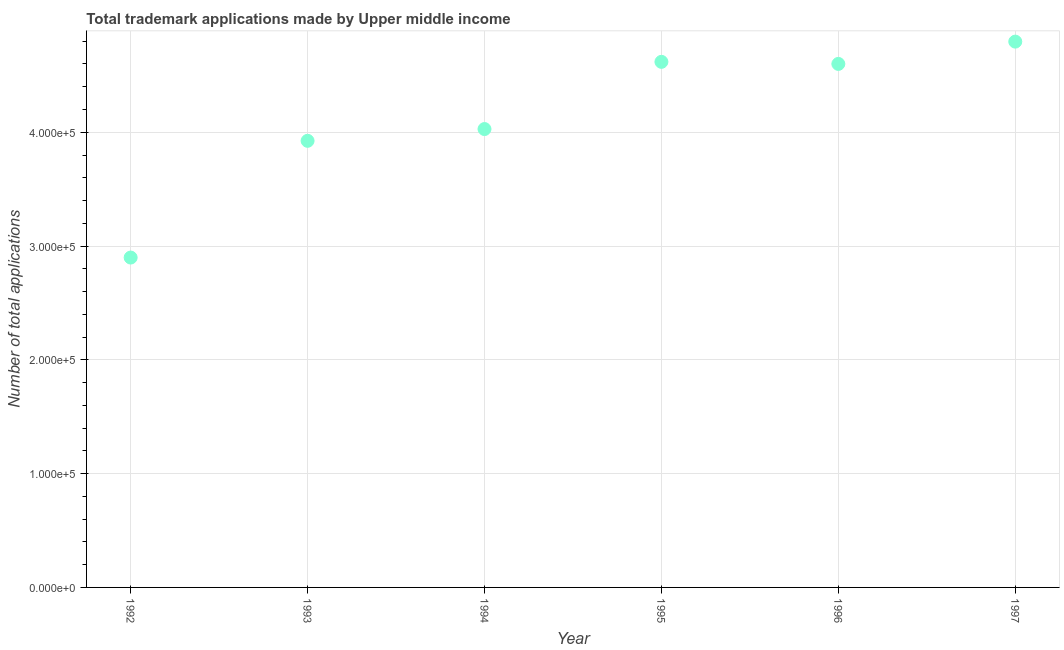What is the number of trademark applications in 1994?
Provide a short and direct response. 4.03e+05. Across all years, what is the maximum number of trademark applications?
Provide a short and direct response. 4.80e+05. Across all years, what is the minimum number of trademark applications?
Keep it short and to the point. 2.90e+05. In which year was the number of trademark applications maximum?
Your response must be concise. 1997. In which year was the number of trademark applications minimum?
Your answer should be very brief. 1992. What is the sum of the number of trademark applications?
Offer a very short reply. 2.49e+06. What is the difference between the number of trademark applications in 1992 and 1996?
Offer a terse response. -1.70e+05. What is the average number of trademark applications per year?
Provide a succinct answer. 4.14e+05. What is the median number of trademark applications?
Offer a very short reply. 4.31e+05. Do a majority of the years between 1992 and 1996 (inclusive) have number of trademark applications greater than 40000 ?
Provide a short and direct response. Yes. What is the ratio of the number of trademark applications in 1994 to that in 1995?
Your answer should be very brief. 0.87. Is the number of trademark applications in 1996 less than that in 1997?
Keep it short and to the point. Yes. What is the difference between the highest and the second highest number of trademark applications?
Make the answer very short. 1.78e+04. Is the sum of the number of trademark applications in 1993 and 1997 greater than the maximum number of trademark applications across all years?
Ensure brevity in your answer.  Yes. What is the difference between the highest and the lowest number of trademark applications?
Give a very brief answer. 1.90e+05. In how many years, is the number of trademark applications greater than the average number of trademark applications taken over all years?
Make the answer very short. 3. How many years are there in the graph?
Give a very brief answer. 6. Are the values on the major ticks of Y-axis written in scientific E-notation?
Keep it short and to the point. Yes. What is the title of the graph?
Offer a terse response. Total trademark applications made by Upper middle income. What is the label or title of the Y-axis?
Provide a short and direct response. Number of total applications. What is the Number of total applications in 1992?
Your answer should be compact. 2.90e+05. What is the Number of total applications in 1993?
Make the answer very short. 3.92e+05. What is the Number of total applications in 1994?
Give a very brief answer. 4.03e+05. What is the Number of total applications in 1995?
Provide a succinct answer. 4.62e+05. What is the Number of total applications in 1996?
Provide a succinct answer. 4.60e+05. What is the Number of total applications in 1997?
Your answer should be very brief. 4.80e+05. What is the difference between the Number of total applications in 1992 and 1993?
Ensure brevity in your answer.  -1.03e+05. What is the difference between the Number of total applications in 1992 and 1994?
Make the answer very short. -1.13e+05. What is the difference between the Number of total applications in 1992 and 1995?
Give a very brief answer. -1.72e+05. What is the difference between the Number of total applications in 1992 and 1996?
Your response must be concise. -1.70e+05. What is the difference between the Number of total applications in 1992 and 1997?
Offer a terse response. -1.90e+05. What is the difference between the Number of total applications in 1993 and 1994?
Ensure brevity in your answer.  -1.03e+04. What is the difference between the Number of total applications in 1993 and 1995?
Your response must be concise. -6.94e+04. What is the difference between the Number of total applications in 1993 and 1996?
Your answer should be compact. -6.76e+04. What is the difference between the Number of total applications in 1993 and 1997?
Your answer should be very brief. -8.72e+04. What is the difference between the Number of total applications in 1994 and 1995?
Make the answer very short. -5.90e+04. What is the difference between the Number of total applications in 1994 and 1996?
Offer a very short reply. -5.72e+04. What is the difference between the Number of total applications in 1994 and 1997?
Offer a very short reply. -7.68e+04. What is the difference between the Number of total applications in 1995 and 1996?
Your response must be concise. 1810. What is the difference between the Number of total applications in 1995 and 1997?
Ensure brevity in your answer.  -1.78e+04. What is the difference between the Number of total applications in 1996 and 1997?
Ensure brevity in your answer.  -1.96e+04. What is the ratio of the Number of total applications in 1992 to that in 1993?
Provide a succinct answer. 0.74. What is the ratio of the Number of total applications in 1992 to that in 1994?
Offer a terse response. 0.72. What is the ratio of the Number of total applications in 1992 to that in 1995?
Your answer should be compact. 0.63. What is the ratio of the Number of total applications in 1992 to that in 1996?
Keep it short and to the point. 0.63. What is the ratio of the Number of total applications in 1992 to that in 1997?
Keep it short and to the point. 0.6. What is the ratio of the Number of total applications in 1993 to that in 1995?
Your answer should be compact. 0.85. What is the ratio of the Number of total applications in 1993 to that in 1996?
Offer a terse response. 0.85. What is the ratio of the Number of total applications in 1993 to that in 1997?
Give a very brief answer. 0.82. What is the ratio of the Number of total applications in 1994 to that in 1995?
Provide a succinct answer. 0.87. What is the ratio of the Number of total applications in 1994 to that in 1996?
Provide a short and direct response. 0.88. What is the ratio of the Number of total applications in 1994 to that in 1997?
Ensure brevity in your answer.  0.84. What is the ratio of the Number of total applications in 1995 to that in 1996?
Provide a short and direct response. 1. What is the ratio of the Number of total applications in 1996 to that in 1997?
Your response must be concise. 0.96. 